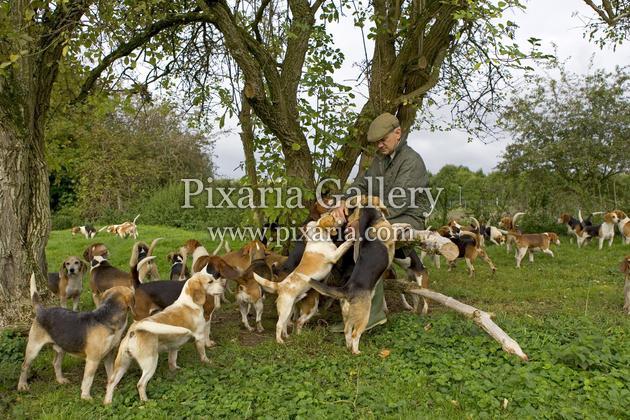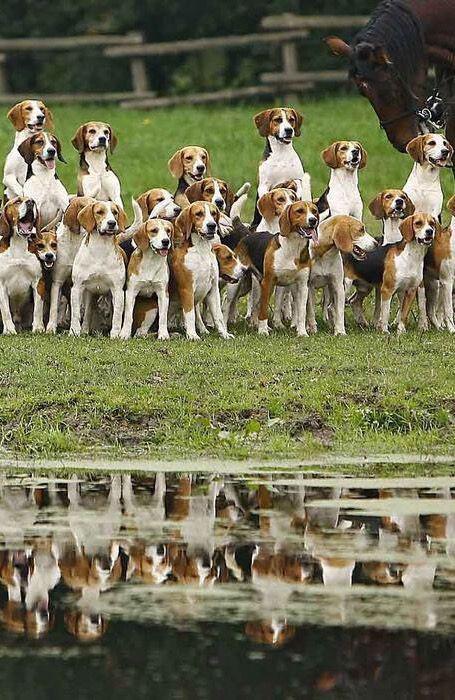The first image is the image on the left, the second image is the image on the right. Assess this claim about the two images: "The dogs in the left image are walking toward the camera in a large group.". Correct or not? Answer yes or no. No. The first image is the image on the left, the second image is the image on the right. For the images shown, is this caption "An image shows a horizontal row of beagle hounds, with no humans present." true? Answer yes or no. Yes. 